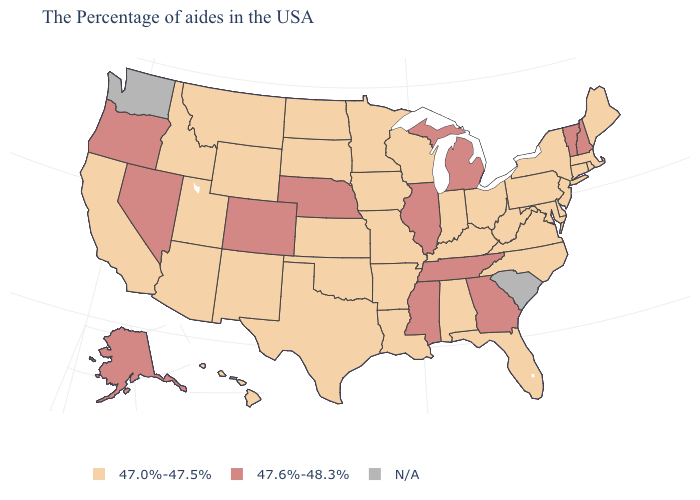How many symbols are there in the legend?
Quick response, please. 3. What is the value of Indiana?
Be succinct. 47.0%-47.5%. Does Michigan have the highest value in the USA?
Be succinct. Yes. Does Nebraska have the lowest value in the MidWest?
Give a very brief answer. No. Name the states that have a value in the range N/A?
Answer briefly. South Carolina, Washington. Name the states that have a value in the range N/A?
Short answer required. South Carolina, Washington. Which states have the highest value in the USA?
Give a very brief answer. New Hampshire, Vermont, Georgia, Michigan, Tennessee, Illinois, Mississippi, Nebraska, Colorado, Nevada, Oregon, Alaska. What is the value of Florida?
Answer briefly. 47.0%-47.5%. How many symbols are there in the legend?
Keep it brief. 3. Does New Mexico have the lowest value in the USA?
Write a very short answer. Yes. Name the states that have a value in the range 47.0%-47.5%?
Quick response, please. Maine, Massachusetts, Rhode Island, Connecticut, New York, New Jersey, Delaware, Maryland, Pennsylvania, Virginia, North Carolina, West Virginia, Ohio, Florida, Kentucky, Indiana, Alabama, Wisconsin, Louisiana, Missouri, Arkansas, Minnesota, Iowa, Kansas, Oklahoma, Texas, South Dakota, North Dakota, Wyoming, New Mexico, Utah, Montana, Arizona, Idaho, California, Hawaii. What is the highest value in states that border Connecticut?
Quick response, please. 47.0%-47.5%. How many symbols are there in the legend?
Quick response, please. 3. What is the value of Maryland?
Answer briefly. 47.0%-47.5%. 